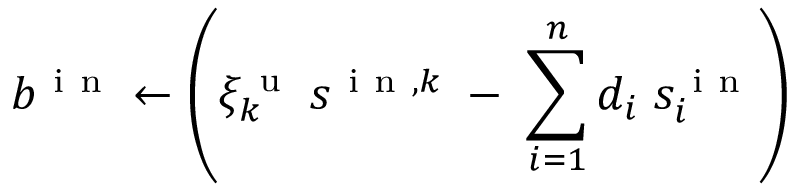Convert formula to latex. <formula><loc_0><loc_0><loc_500><loc_500>b ^ { i n } \gets \left ( \xi _ { k } ^ { u } \, s ^ { i n , k } \, - \, \sum _ { i = 1 } ^ { n } d _ { i } \, s _ { i } ^ { i n } \right )</formula> 